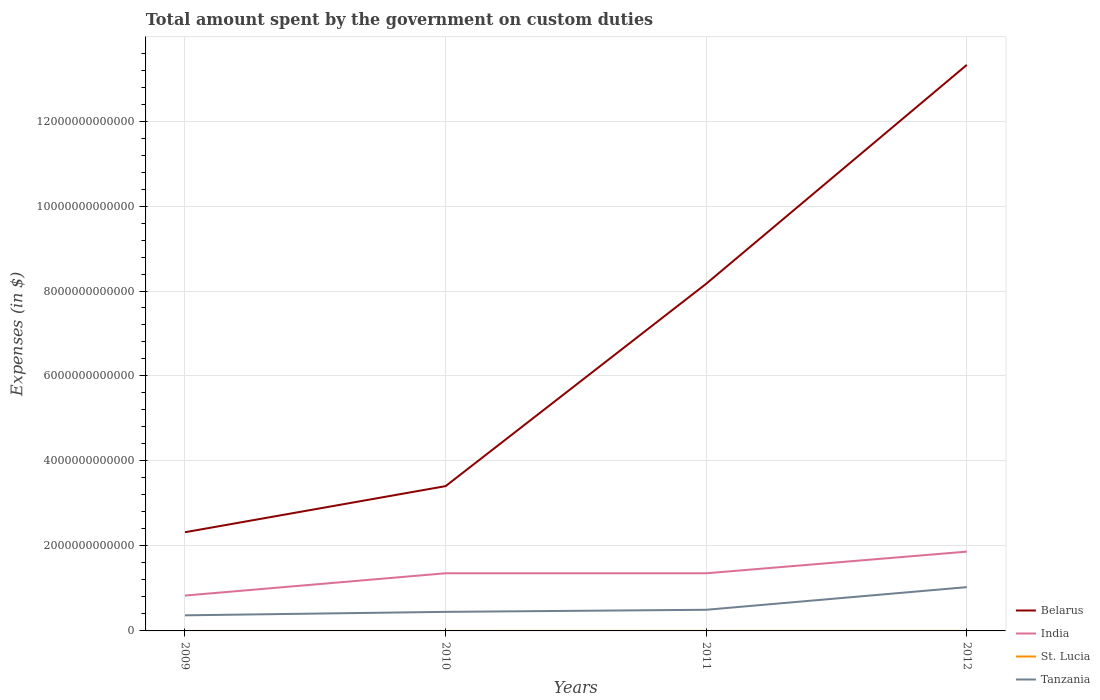Does the line corresponding to St. Lucia intersect with the line corresponding to Tanzania?
Provide a succinct answer. No. Is the number of lines equal to the number of legend labels?
Offer a terse response. Yes. Across all years, what is the maximum amount spent on custom duties by the government in Belarus?
Ensure brevity in your answer.  2.32e+12. In which year was the amount spent on custom duties by the government in St. Lucia maximum?
Ensure brevity in your answer.  2009. What is the total amount spent on custom duties by the government in Tanzania in the graph?
Offer a very short reply. -5.82e+11. What is the difference between the highest and the second highest amount spent on custom duties by the government in India?
Ensure brevity in your answer.  1.03e+12. Is the amount spent on custom duties by the government in St. Lucia strictly greater than the amount spent on custom duties by the government in India over the years?
Offer a terse response. Yes. How many lines are there?
Offer a very short reply. 4. How many years are there in the graph?
Make the answer very short. 4. What is the difference between two consecutive major ticks on the Y-axis?
Offer a terse response. 2.00e+12. Does the graph contain any zero values?
Make the answer very short. No. Does the graph contain grids?
Offer a terse response. Yes. How many legend labels are there?
Keep it short and to the point. 4. What is the title of the graph?
Your answer should be compact. Total amount spent by the government on custom duties. What is the label or title of the X-axis?
Give a very brief answer. Years. What is the label or title of the Y-axis?
Offer a terse response. Expenses (in $). What is the Expenses (in $) of Belarus in 2009?
Keep it short and to the point. 2.32e+12. What is the Expenses (in $) in India in 2009?
Your answer should be very brief. 8.32e+11. What is the Expenses (in $) in St. Lucia in 2009?
Your answer should be compact. 1.55e+08. What is the Expenses (in $) in Tanzania in 2009?
Your answer should be compact. 3.67e+11. What is the Expenses (in $) in Belarus in 2010?
Keep it short and to the point. 3.41e+12. What is the Expenses (in $) in India in 2010?
Provide a succinct answer. 1.36e+12. What is the Expenses (in $) of St. Lucia in 2010?
Offer a terse response. 1.61e+08. What is the Expenses (in $) in Tanzania in 2010?
Make the answer very short. 4.49e+11. What is the Expenses (in $) in Belarus in 2011?
Your answer should be compact. 8.17e+12. What is the Expenses (in $) in India in 2011?
Offer a very short reply. 1.36e+12. What is the Expenses (in $) in St. Lucia in 2011?
Provide a short and direct response. 1.75e+08. What is the Expenses (in $) of Tanzania in 2011?
Your answer should be very brief. 4.98e+11. What is the Expenses (in $) in Belarus in 2012?
Your answer should be compact. 1.33e+13. What is the Expenses (in $) in India in 2012?
Keep it short and to the point. 1.87e+12. What is the Expenses (in $) of St. Lucia in 2012?
Offer a very short reply. 1.71e+08. What is the Expenses (in $) in Tanzania in 2012?
Ensure brevity in your answer.  1.03e+12. Across all years, what is the maximum Expenses (in $) of Belarus?
Offer a terse response. 1.33e+13. Across all years, what is the maximum Expenses (in $) in India?
Offer a terse response. 1.87e+12. Across all years, what is the maximum Expenses (in $) in St. Lucia?
Offer a very short reply. 1.75e+08. Across all years, what is the maximum Expenses (in $) of Tanzania?
Make the answer very short. 1.03e+12. Across all years, what is the minimum Expenses (in $) in Belarus?
Make the answer very short. 2.32e+12. Across all years, what is the minimum Expenses (in $) of India?
Provide a short and direct response. 8.32e+11. Across all years, what is the minimum Expenses (in $) of St. Lucia?
Provide a succinct answer. 1.55e+08. Across all years, what is the minimum Expenses (in $) in Tanzania?
Your answer should be very brief. 3.67e+11. What is the total Expenses (in $) in Belarus in the graph?
Keep it short and to the point. 2.72e+13. What is the total Expenses (in $) in India in the graph?
Provide a short and direct response. 5.41e+12. What is the total Expenses (in $) in St. Lucia in the graph?
Make the answer very short. 6.61e+08. What is the total Expenses (in $) in Tanzania in the graph?
Keep it short and to the point. 2.34e+12. What is the difference between the Expenses (in $) of Belarus in 2009 and that in 2010?
Make the answer very short. -1.09e+12. What is the difference between the Expenses (in $) in India in 2009 and that in 2010?
Provide a short and direct response. -5.24e+11. What is the difference between the Expenses (in $) in St. Lucia in 2009 and that in 2010?
Your answer should be compact. -6.20e+06. What is the difference between the Expenses (in $) of Tanzania in 2009 and that in 2010?
Provide a short and direct response. -8.16e+1. What is the difference between the Expenses (in $) of Belarus in 2009 and that in 2011?
Your answer should be compact. -5.85e+12. What is the difference between the Expenses (in $) of India in 2009 and that in 2011?
Provide a short and direct response. -5.24e+11. What is the difference between the Expenses (in $) in St. Lucia in 2009 and that in 2011?
Ensure brevity in your answer.  -1.98e+07. What is the difference between the Expenses (in $) of Tanzania in 2009 and that in 2011?
Keep it short and to the point. -1.31e+11. What is the difference between the Expenses (in $) in Belarus in 2009 and that in 2012?
Provide a short and direct response. -1.10e+13. What is the difference between the Expenses (in $) in India in 2009 and that in 2012?
Keep it short and to the point. -1.03e+12. What is the difference between the Expenses (in $) of St. Lucia in 2009 and that in 2012?
Give a very brief answer. -1.57e+07. What is the difference between the Expenses (in $) in Tanzania in 2009 and that in 2012?
Provide a succinct answer. -6.63e+11. What is the difference between the Expenses (in $) of Belarus in 2010 and that in 2011?
Offer a very short reply. -4.76e+12. What is the difference between the Expenses (in $) of India in 2010 and that in 2011?
Make the answer very short. 0. What is the difference between the Expenses (in $) of St. Lucia in 2010 and that in 2011?
Keep it short and to the point. -1.36e+07. What is the difference between the Expenses (in $) in Tanzania in 2010 and that in 2011?
Make the answer very short. -4.90e+1. What is the difference between the Expenses (in $) in Belarus in 2010 and that in 2012?
Offer a very short reply. -9.91e+12. What is the difference between the Expenses (in $) in India in 2010 and that in 2012?
Offer a terse response. -5.09e+11. What is the difference between the Expenses (in $) in St. Lucia in 2010 and that in 2012?
Offer a very short reply. -9.50e+06. What is the difference between the Expenses (in $) of Tanzania in 2010 and that in 2012?
Offer a terse response. -5.82e+11. What is the difference between the Expenses (in $) of Belarus in 2011 and that in 2012?
Your response must be concise. -5.15e+12. What is the difference between the Expenses (in $) in India in 2011 and that in 2012?
Provide a succinct answer. -5.09e+11. What is the difference between the Expenses (in $) in St. Lucia in 2011 and that in 2012?
Your answer should be compact. 4.10e+06. What is the difference between the Expenses (in $) of Tanzania in 2011 and that in 2012?
Provide a short and direct response. -5.33e+11. What is the difference between the Expenses (in $) of Belarus in 2009 and the Expenses (in $) of India in 2010?
Offer a very short reply. 9.66e+11. What is the difference between the Expenses (in $) of Belarus in 2009 and the Expenses (in $) of St. Lucia in 2010?
Give a very brief answer. 2.32e+12. What is the difference between the Expenses (in $) in Belarus in 2009 and the Expenses (in $) in Tanzania in 2010?
Your response must be concise. 1.87e+12. What is the difference between the Expenses (in $) of India in 2009 and the Expenses (in $) of St. Lucia in 2010?
Your answer should be very brief. 8.32e+11. What is the difference between the Expenses (in $) of India in 2009 and the Expenses (in $) of Tanzania in 2010?
Give a very brief answer. 3.84e+11. What is the difference between the Expenses (in $) of St. Lucia in 2009 and the Expenses (in $) of Tanzania in 2010?
Offer a very short reply. -4.48e+11. What is the difference between the Expenses (in $) of Belarus in 2009 and the Expenses (in $) of India in 2011?
Ensure brevity in your answer.  9.66e+11. What is the difference between the Expenses (in $) in Belarus in 2009 and the Expenses (in $) in St. Lucia in 2011?
Your response must be concise. 2.32e+12. What is the difference between the Expenses (in $) of Belarus in 2009 and the Expenses (in $) of Tanzania in 2011?
Give a very brief answer. 1.82e+12. What is the difference between the Expenses (in $) of India in 2009 and the Expenses (in $) of St. Lucia in 2011?
Offer a very short reply. 8.32e+11. What is the difference between the Expenses (in $) of India in 2009 and the Expenses (in $) of Tanzania in 2011?
Your answer should be very brief. 3.35e+11. What is the difference between the Expenses (in $) in St. Lucia in 2009 and the Expenses (in $) in Tanzania in 2011?
Your answer should be compact. -4.98e+11. What is the difference between the Expenses (in $) in Belarus in 2009 and the Expenses (in $) in India in 2012?
Provide a short and direct response. 4.56e+11. What is the difference between the Expenses (in $) of Belarus in 2009 and the Expenses (in $) of St. Lucia in 2012?
Your answer should be compact. 2.32e+12. What is the difference between the Expenses (in $) in Belarus in 2009 and the Expenses (in $) in Tanzania in 2012?
Offer a terse response. 1.29e+12. What is the difference between the Expenses (in $) of India in 2009 and the Expenses (in $) of St. Lucia in 2012?
Make the answer very short. 8.32e+11. What is the difference between the Expenses (in $) in India in 2009 and the Expenses (in $) in Tanzania in 2012?
Provide a short and direct response. -1.98e+11. What is the difference between the Expenses (in $) in St. Lucia in 2009 and the Expenses (in $) in Tanzania in 2012?
Make the answer very short. -1.03e+12. What is the difference between the Expenses (in $) of Belarus in 2010 and the Expenses (in $) of India in 2011?
Your response must be concise. 2.05e+12. What is the difference between the Expenses (in $) in Belarus in 2010 and the Expenses (in $) in St. Lucia in 2011?
Keep it short and to the point. 3.41e+12. What is the difference between the Expenses (in $) in Belarus in 2010 and the Expenses (in $) in Tanzania in 2011?
Your answer should be compact. 2.91e+12. What is the difference between the Expenses (in $) of India in 2010 and the Expenses (in $) of St. Lucia in 2011?
Keep it short and to the point. 1.36e+12. What is the difference between the Expenses (in $) in India in 2010 and the Expenses (in $) in Tanzania in 2011?
Make the answer very short. 8.59e+11. What is the difference between the Expenses (in $) of St. Lucia in 2010 and the Expenses (in $) of Tanzania in 2011?
Make the answer very short. -4.98e+11. What is the difference between the Expenses (in $) of Belarus in 2010 and the Expenses (in $) of India in 2012?
Offer a very short reply. 1.54e+12. What is the difference between the Expenses (in $) in Belarus in 2010 and the Expenses (in $) in St. Lucia in 2012?
Your answer should be compact. 3.41e+12. What is the difference between the Expenses (in $) in Belarus in 2010 and the Expenses (in $) in Tanzania in 2012?
Keep it short and to the point. 2.38e+12. What is the difference between the Expenses (in $) of India in 2010 and the Expenses (in $) of St. Lucia in 2012?
Provide a short and direct response. 1.36e+12. What is the difference between the Expenses (in $) of India in 2010 and the Expenses (in $) of Tanzania in 2012?
Your response must be concise. 3.26e+11. What is the difference between the Expenses (in $) of St. Lucia in 2010 and the Expenses (in $) of Tanzania in 2012?
Make the answer very short. -1.03e+12. What is the difference between the Expenses (in $) of Belarus in 2011 and the Expenses (in $) of India in 2012?
Your response must be concise. 6.30e+12. What is the difference between the Expenses (in $) in Belarus in 2011 and the Expenses (in $) in St. Lucia in 2012?
Ensure brevity in your answer.  8.17e+12. What is the difference between the Expenses (in $) of Belarus in 2011 and the Expenses (in $) of Tanzania in 2012?
Offer a very short reply. 7.14e+12. What is the difference between the Expenses (in $) in India in 2011 and the Expenses (in $) in St. Lucia in 2012?
Give a very brief answer. 1.36e+12. What is the difference between the Expenses (in $) of India in 2011 and the Expenses (in $) of Tanzania in 2012?
Make the answer very short. 3.26e+11. What is the difference between the Expenses (in $) in St. Lucia in 2011 and the Expenses (in $) in Tanzania in 2012?
Offer a terse response. -1.03e+12. What is the average Expenses (in $) of Belarus per year?
Your response must be concise. 6.81e+12. What is the average Expenses (in $) in India per year?
Provide a short and direct response. 1.35e+12. What is the average Expenses (in $) in St. Lucia per year?
Your answer should be very brief. 1.65e+08. What is the average Expenses (in $) of Tanzania per year?
Your answer should be very brief. 5.86e+11. In the year 2009, what is the difference between the Expenses (in $) of Belarus and Expenses (in $) of India?
Give a very brief answer. 1.49e+12. In the year 2009, what is the difference between the Expenses (in $) in Belarus and Expenses (in $) in St. Lucia?
Ensure brevity in your answer.  2.32e+12. In the year 2009, what is the difference between the Expenses (in $) in Belarus and Expenses (in $) in Tanzania?
Your answer should be very brief. 1.96e+12. In the year 2009, what is the difference between the Expenses (in $) of India and Expenses (in $) of St. Lucia?
Your answer should be very brief. 8.32e+11. In the year 2009, what is the difference between the Expenses (in $) of India and Expenses (in $) of Tanzania?
Provide a succinct answer. 4.65e+11. In the year 2009, what is the difference between the Expenses (in $) in St. Lucia and Expenses (in $) in Tanzania?
Keep it short and to the point. -3.67e+11. In the year 2010, what is the difference between the Expenses (in $) of Belarus and Expenses (in $) of India?
Make the answer very short. 2.05e+12. In the year 2010, what is the difference between the Expenses (in $) of Belarus and Expenses (in $) of St. Lucia?
Ensure brevity in your answer.  3.41e+12. In the year 2010, what is the difference between the Expenses (in $) in Belarus and Expenses (in $) in Tanzania?
Keep it short and to the point. 2.96e+12. In the year 2010, what is the difference between the Expenses (in $) in India and Expenses (in $) in St. Lucia?
Offer a very short reply. 1.36e+12. In the year 2010, what is the difference between the Expenses (in $) of India and Expenses (in $) of Tanzania?
Make the answer very short. 9.08e+11. In the year 2010, what is the difference between the Expenses (in $) in St. Lucia and Expenses (in $) in Tanzania?
Offer a terse response. -4.48e+11. In the year 2011, what is the difference between the Expenses (in $) of Belarus and Expenses (in $) of India?
Provide a short and direct response. 6.81e+12. In the year 2011, what is the difference between the Expenses (in $) in Belarus and Expenses (in $) in St. Lucia?
Ensure brevity in your answer.  8.17e+12. In the year 2011, what is the difference between the Expenses (in $) of Belarus and Expenses (in $) of Tanzania?
Keep it short and to the point. 7.67e+12. In the year 2011, what is the difference between the Expenses (in $) in India and Expenses (in $) in St. Lucia?
Offer a terse response. 1.36e+12. In the year 2011, what is the difference between the Expenses (in $) in India and Expenses (in $) in Tanzania?
Give a very brief answer. 8.59e+11. In the year 2011, what is the difference between the Expenses (in $) of St. Lucia and Expenses (in $) of Tanzania?
Ensure brevity in your answer.  -4.98e+11. In the year 2012, what is the difference between the Expenses (in $) of Belarus and Expenses (in $) of India?
Provide a succinct answer. 1.15e+13. In the year 2012, what is the difference between the Expenses (in $) of Belarus and Expenses (in $) of St. Lucia?
Provide a short and direct response. 1.33e+13. In the year 2012, what is the difference between the Expenses (in $) of Belarus and Expenses (in $) of Tanzania?
Offer a very short reply. 1.23e+13. In the year 2012, what is the difference between the Expenses (in $) in India and Expenses (in $) in St. Lucia?
Offer a very short reply. 1.87e+12. In the year 2012, what is the difference between the Expenses (in $) in India and Expenses (in $) in Tanzania?
Your answer should be very brief. 8.36e+11. In the year 2012, what is the difference between the Expenses (in $) of St. Lucia and Expenses (in $) of Tanzania?
Make the answer very short. -1.03e+12. What is the ratio of the Expenses (in $) in Belarus in 2009 to that in 2010?
Ensure brevity in your answer.  0.68. What is the ratio of the Expenses (in $) in India in 2009 to that in 2010?
Your answer should be compact. 0.61. What is the ratio of the Expenses (in $) in St. Lucia in 2009 to that in 2010?
Make the answer very short. 0.96. What is the ratio of the Expenses (in $) in Tanzania in 2009 to that in 2010?
Offer a terse response. 0.82. What is the ratio of the Expenses (in $) of Belarus in 2009 to that in 2011?
Your answer should be very brief. 0.28. What is the ratio of the Expenses (in $) in India in 2009 to that in 2011?
Ensure brevity in your answer.  0.61. What is the ratio of the Expenses (in $) of St. Lucia in 2009 to that in 2011?
Offer a very short reply. 0.89. What is the ratio of the Expenses (in $) of Tanzania in 2009 to that in 2011?
Offer a terse response. 0.74. What is the ratio of the Expenses (in $) of Belarus in 2009 to that in 2012?
Offer a very short reply. 0.17. What is the ratio of the Expenses (in $) of India in 2009 to that in 2012?
Ensure brevity in your answer.  0.45. What is the ratio of the Expenses (in $) in St. Lucia in 2009 to that in 2012?
Keep it short and to the point. 0.91. What is the ratio of the Expenses (in $) in Tanzania in 2009 to that in 2012?
Ensure brevity in your answer.  0.36. What is the ratio of the Expenses (in $) of Belarus in 2010 to that in 2011?
Provide a short and direct response. 0.42. What is the ratio of the Expenses (in $) of India in 2010 to that in 2011?
Make the answer very short. 1. What is the ratio of the Expenses (in $) in St. Lucia in 2010 to that in 2011?
Your answer should be very brief. 0.92. What is the ratio of the Expenses (in $) of Tanzania in 2010 to that in 2011?
Ensure brevity in your answer.  0.9. What is the ratio of the Expenses (in $) in Belarus in 2010 to that in 2012?
Offer a terse response. 0.26. What is the ratio of the Expenses (in $) in India in 2010 to that in 2012?
Your response must be concise. 0.73. What is the ratio of the Expenses (in $) of St. Lucia in 2010 to that in 2012?
Make the answer very short. 0.94. What is the ratio of the Expenses (in $) of Tanzania in 2010 to that in 2012?
Offer a very short reply. 0.44. What is the ratio of the Expenses (in $) in Belarus in 2011 to that in 2012?
Your response must be concise. 0.61. What is the ratio of the Expenses (in $) of India in 2011 to that in 2012?
Offer a terse response. 0.73. What is the ratio of the Expenses (in $) in Tanzania in 2011 to that in 2012?
Provide a succinct answer. 0.48. What is the difference between the highest and the second highest Expenses (in $) in Belarus?
Offer a terse response. 5.15e+12. What is the difference between the highest and the second highest Expenses (in $) of India?
Offer a terse response. 5.09e+11. What is the difference between the highest and the second highest Expenses (in $) of St. Lucia?
Your answer should be compact. 4.10e+06. What is the difference between the highest and the second highest Expenses (in $) in Tanzania?
Offer a terse response. 5.33e+11. What is the difference between the highest and the lowest Expenses (in $) of Belarus?
Offer a very short reply. 1.10e+13. What is the difference between the highest and the lowest Expenses (in $) of India?
Your answer should be compact. 1.03e+12. What is the difference between the highest and the lowest Expenses (in $) in St. Lucia?
Offer a terse response. 1.98e+07. What is the difference between the highest and the lowest Expenses (in $) of Tanzania?
Keep it short and to the point. 6.63e+11. 